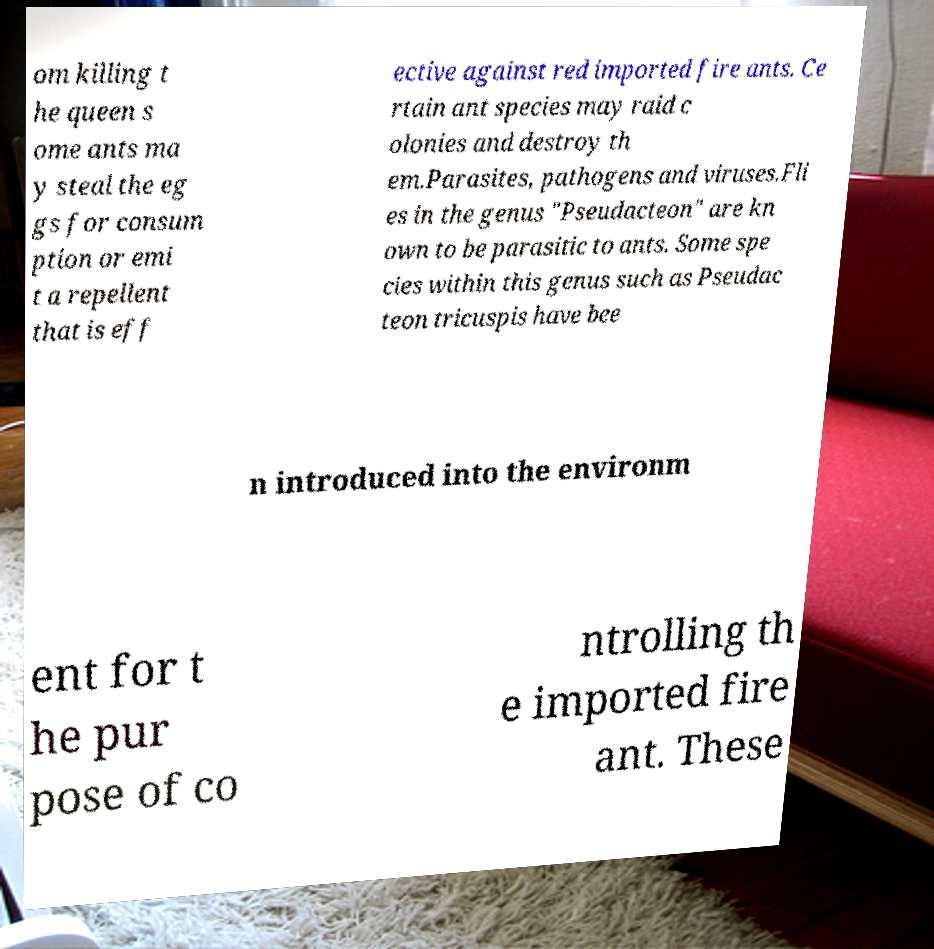There's text embedded in this image that I need extracted. Can you transcribe it verbatim? om killing t he queen s ome ants ma y steal the eg gs for consum ption or emi t a repellent that is eff ective against red imported fire ants. Ce rtain ant species may raid c olonies and destroy th em.Parasites, pathogens and viruses.Fli es in the genus "Pseudacteon" are kn own to be parasitic to ants. Some spe cies within this genus such as Pseudac teon tricuspis have bee n introduced into the environm ent for t he pur pose of co ntrolling th e imported fire ant. These 